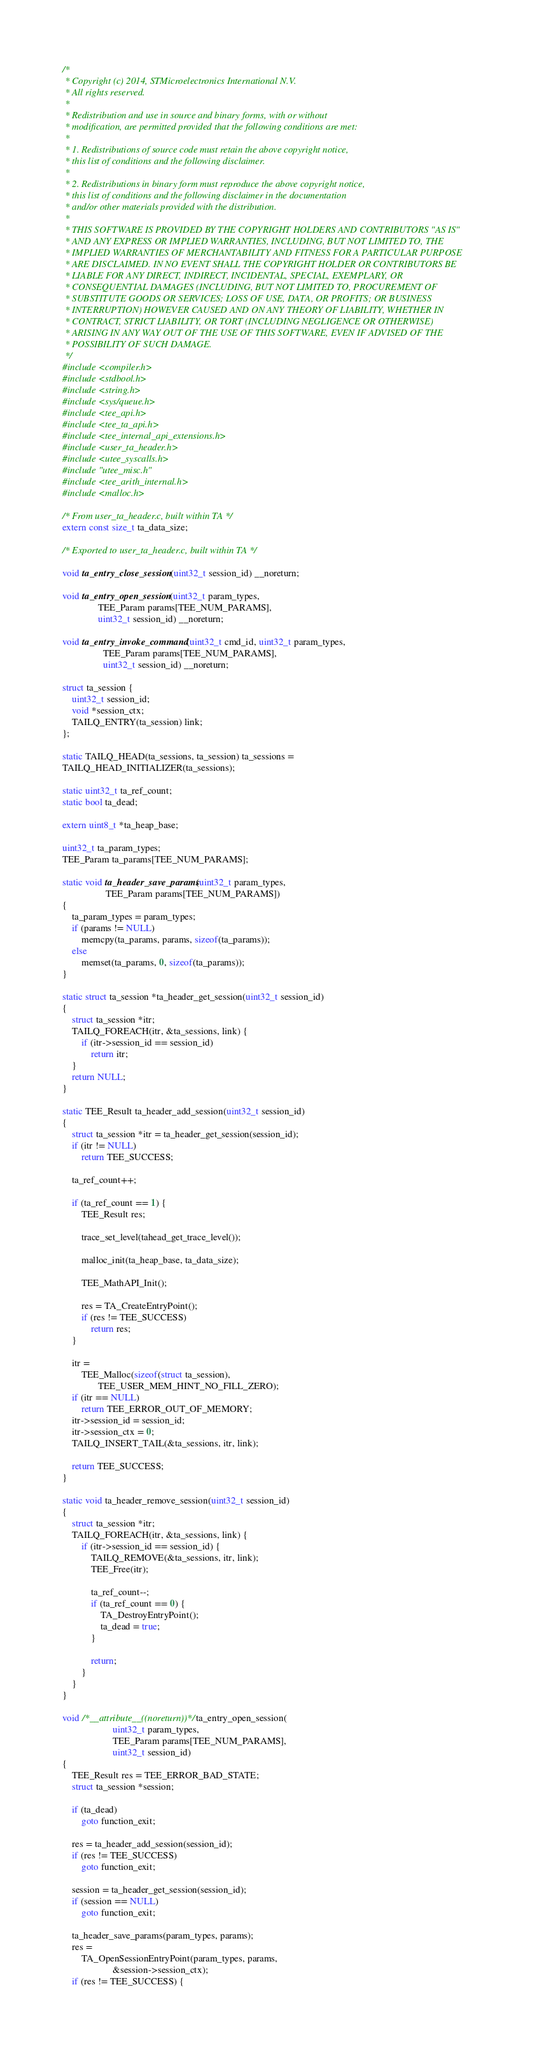<code> <loc_0><loc_0><loc_500><loc_500><_C_>/*
 * Copyright (c) 2014, STMicroelectronics International N.V.
 * All rights reserved.
 *
 * Redistribution and use in source and binary forms, with or without
 * modification, are permitted provided that the following conditions are met:
 *
 * 1. Redistributions of source code must retain the above copyright notice,
 * this list of conditions and the following disclaimer.
 *
 * 2. Redistributions in binary form must reproduce the above copyright notice,
 * this list of conditions and the following disclaimer in the documentation
 * and/or other materials provided with the distribution.
 *
 * THIS SOFTWARE IS PROVIDED BY THE COPYRIGHT HOLDERS AND CONTRIBUTORS "AS IS"
 * AND ANY EXPRESS OR IMPLIED WARRANTIES, INCLUDING, BUT NOT LIMITED TO, THE
 * IMPLIED WARRANTIES OF MERCHANTABILITY AND FITNESS FOR A PARTICULAR PURPOSE
 * ARE DISCLAIMED. IN NO EVENT SHALL THE COPYRIGHT HOLDER OR CONTRIBUTORS BE
 * LIABLE FOR ANY DIRECT, INDIRECT, INCIDENTAL, SPECIAL, EXEMPLARY, OR
 * CONSEQUENTIAL DAMAGES (INCLUDING, BUT NOT LIMITED TO, PROCUREMENT OF
 * SUBSTITUTE GOODS OR SERVICES; LOSS OF USE, DATA, OR PROFITS; OR BUSINESS
 * INTERRUPTION) HOWEVER CAUSED AND ON ANY THEORY OF LIABILITY, WHETHER IN
 * CONTRACT, STRICT LIABILITY, OR TORT (INCLUDING NEGLIGENCE OR OTHERWISE)
 * ARISING IN ANY WAY OUT OF THE USE OF THIS SOFTWARE, EVEN IF ADVISED OF THE
 * POSSIBILITY OF SUCH DAMAGE.
 */
#include <compiler.h>
#include <stdbool.h>
#include <string.h>
#include <sys/queue.h>
#include <tee_api.h>
#include <tee_ta_api.h>
#include <tee_internal_api_extensions.h>
#include <user_ta_header.h>
#include <utee_syscalls.h>
#include "utee_misc.h"
#include <tee_arith_internal.h>
#include <malloc.h>

/* From user_ta_header.c, built within TA */
extern const size_t ta_data_size;

/* Exported to user_ta_header.c, built within TA */

void ta_entry_close_session(uint32_t session_id) __noreturn;

void ta_entry_open_session(uint32_t param_types,
			   TEE_Param params[TEE_NUM_PARAMS],
			   uint32_t session_id) __noreturn;

void ta_entry_invoke_command(uint32_t cmd_id, uint32_t param_types,
			     TEE_Param params[TEE_NUM_PARAMS],
			     uint32_t session_id) __noreturn;

struct ta_session {
	uint32_t session_id;
	void *session_ctx;
	TAILQ_ENTRY(ta_session) link;
};

static TAILQ_HEAD(ta_sessions, ta_session) ta_sessions =
TAILQ_HEAD_INITIALIZER(ta_sessions);

static uint32_t ta_ref_count;
static bool ta_dead;

extern uint8_t *ta_heap_base;

uint32_t ta_param_types;
TEE_Param ta_params[TEE_NUM_PARAMS];

static void ta_header_save_params(uint32_t param_types,
				  TEE_Param params[TEE_NUM_PARAMS])
{
	ta_param_types = param_types;
	if (params != NULL)
		memcpy(ta_params, params, sizeof(ta_params));
	else
		memset(ta_params, 0, sizeof(ta_params));
}

static struct ta_session *ta_header_get_session(uint32_t session_id)
{
	struct ta_session *itr;
	TAILQ_FOREACH(itr, &ta_sessions, link) {
		if (itr->session_id == session_id)
			return itr;
	}
	return NULL;
}

static TEE_Result ta_header_add_session(uint32_t session_id)
{
	struct ta_session *itr = ta_header_get_session(session_id);
	if (itr != NULL)
		return TEE_SUCCESS;

	ta_ref_count++;

	if (ta_ref_count == 1) {
		TEE_Result res;

		trace_set_level(tahead_get_trace_level());

		malloc_init(ta_heap_base, ta_data_size);

		TEE_MathAPI_Init();

		res = TA_CreateEntryPoint();
		if (res != TEE_SUCCESS)
			return res;
	}

	itr =
	    TEE_Malloc(sizeof(struct ta_session),
		       TEE_USER_MEM_HINT_NO_FILL_ZERO);
	if (itr == NULL)
		return TEE_ERROR_OUT_OF_MEMORY;
	itr->session_id = session_id;
	itr->session_ctx = 0;
	TAILQ_INSERT_TAIL(&ta_sessions, itr, link);

	return TEE_SUCCESS;
}

static void ta_header_remove_session(uint32_t session_id)
{
	struct ta_session *itr;
	TAILQ_FOREACH(itr, &ta_sessions, link) {
		if (itr->session_id == session_id) {
			TAILQ_REMOVE(&ta_sessions, itr, link);
			TEE_Free(itr);

			ta_ref_count--;
			if (ta_ref_count == 0) {
				TA_DestroyEntryPoint();
				ta_dead = true;
			}

			return;
		}
	}
}

void /*__attribute__((noreturn))*/ ta_entry_open_session(
					 uint32_t param_types,
					 TEE_Param params[TEE_NUM_PARAMS],
					 uint32_t session_id)
{
	TEE_Result res = TEE_ERROR_BAD_STATE;
	struct ta_session *session;

	if (ta_dead)
		goto function_exit;

	res = ta_header_add_session(session_id);
	if (res != TEE_SUCCESS)
		goto function_exit;

	session = ta_header_get_session(session_id);
	if (session == NULL)
		goto function_exit;

	ta_header_save_params(param_types, params);
	res =
	    TA_OpenSessionEntryPoint(param_types, params,
				     &session->session_ctx);
	if (res != TEE_SUCCESS) {</code> 